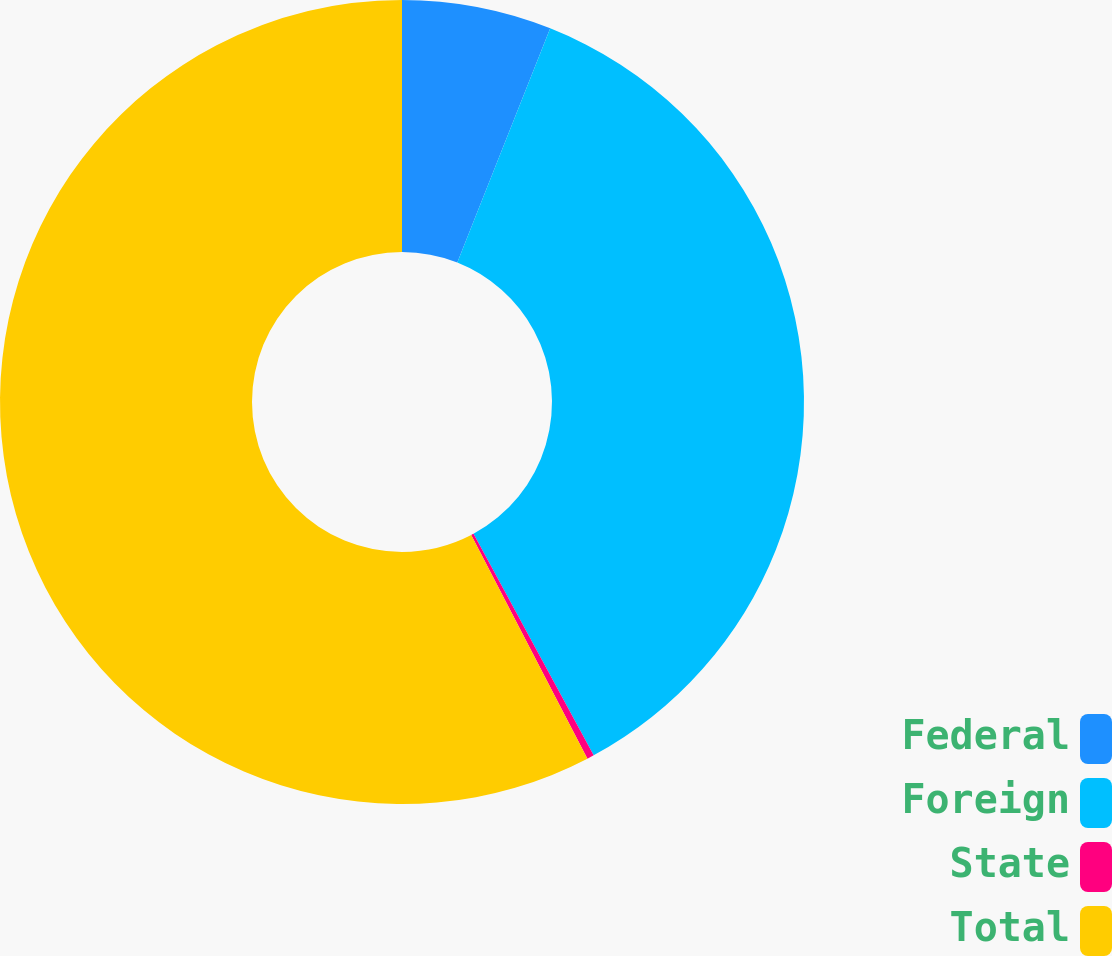Convert chart. <chart><loc_0><loc_0><loc_500><loc_500><pie_chart><fcel>Federal<fcel>Foreign<fcel>State<fcel>Total<nl><fcel>6.01%<fcel>36.08%<fcel>0.28%<fcel>57.63%<nl></chart> 